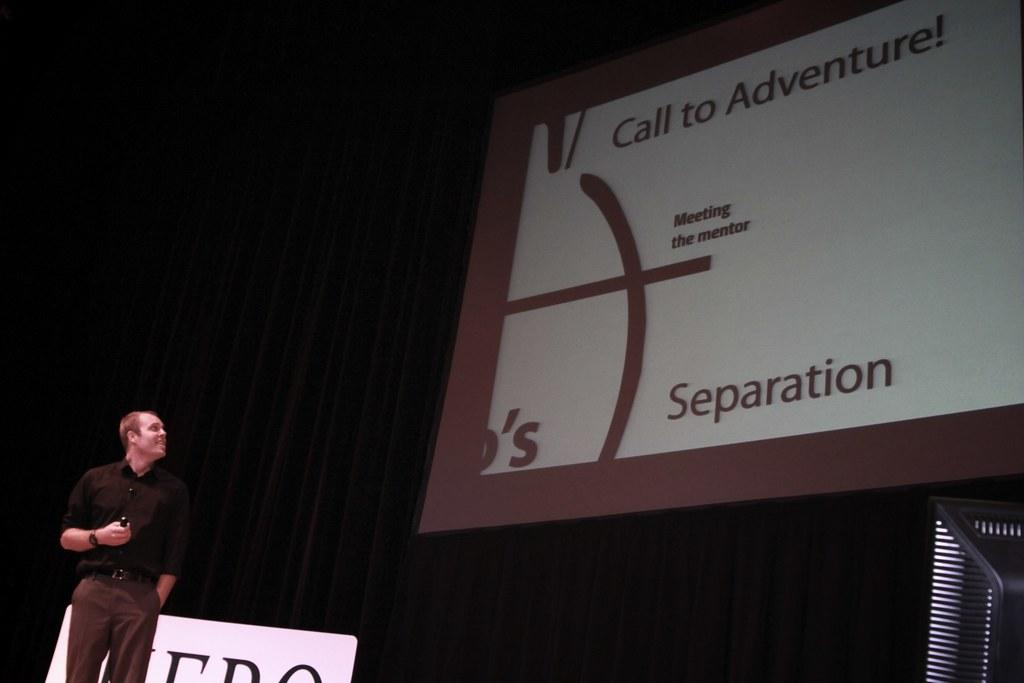What can be seen on the left side of the image? There is a person on the left side of the image. What is located on the right side of the image? There is a screen on the right side of the image. What color is the curtain in the background of the image? The curtain in the background of the image is black. Is the sand on the left side of the image soft and silky? There is no sand present in the image; it features a person on the left side and a screen on the right side. How does the snow look like on the screen in the image? There is no snow present in the image; the screen is not described or depicted in the provided facts. 